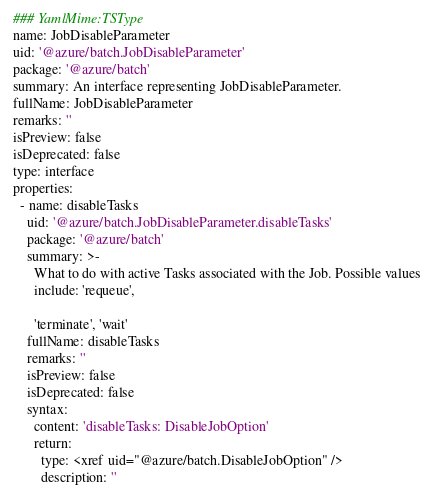Convert code to text. <code><loc_0><loc_0><loc_500><loc_500><_YAML_>### YamlMime:TSType
name: JobDisableParameter
uid: '@azure/batch.JobDisableParameter'
package: '@azure/batch'
summary: An interface representing JobDisableParameter.
fullName: JobDisableParameter
remarks: ''
isPreview: false
isDeprecated: false
type: interface
properties:
  - name: disableTasks
    uid: '@azure/batch.JobDisableParameter.disableTasks'
    package: '@azure/batch'
    summary: >-
      What to do with active Tasks associated with the Job. Possible values
      include: 'requeue',

      'terminate', 'wait'
    fullName: disableTasks
    remarks: ''
    isPreview: false
    isDeprecated: false
    syntax:
      content: 'disableTasks: DisableJobOption'
      return:
        type: <xref uid="@azure/batch.DisableJobOption" />
        description: ''
</code> 